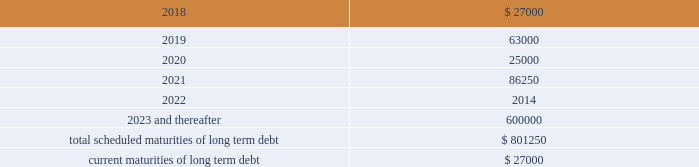Other long term debt in december 2012 , the company entered into a $ 50.0 million recourse loan collateralized by the land , buildings and tenant improvements comprising the company 2019s corporate headquarters .
The loan has a seven year term and maturity date of december 2019 .
The loan bears interest at one month libor plus a margin of 1.50% ( 1.50 % ) , and allows for prepayment without penalty .
The loan includes covenants and events of default substantially consistent with the company 2019s credit agreement discussed above .
The loan also requires prior approval of the lender for certain matters related to the property , including transfers of any interest in the property .
As of december 31 , 2017 and 2016 , the outstanding balance on the loan was $ 40.0 million and $ 42.0 million , respectively .
The weighted average interest rate on the loan was 2.5% ( 2.5 % ) and 2.0% ( 2.0 % ) for the years ended december 31 , 2017 and 2016 , respectively .
The following are the scheduled maturities of long term debt as of december 31 , 2017 : ( in thousands ) .
Interest expense , net was $ 34.5 million , $ 26.4 million , and $ 14.6 million for the years ended december 31 , 2017 , 2016 and 2015 , respectively .
Interest expense includes the amortization of deferred financing costs , bank fees , capital and built-to-suit lease interest and interest expense under the credit and other long term debt facilities .
Amortization of deferred financing costs was $ 1.3 million , $ 1.2 million , and $ 0.8 million for the years ended december 31 , 2017 , 2016 and 2015 , respectively .
The company monitors the financial health and stability of its lenders under the credit and other long term debt facilities , however during any period of significant instability in the credit markets lenders could be negatively impacted in their ability to perform under these facilities .
Commitments and contingencies obligations under operating leases the company leases warehouse space , office facilities , space for its brand and factory house stores and certain equipment under non-cancelable operating leases .
The leases expire at various dates through 2033 , excluding extensions at the company 2019s option , and include provisions for rental adjustments .
The table below includes executed lease agreements for brand and factory house stores that the company did not yet occupy as of december 31 , 2017 and does not include contingent rent the company may incur at its stores based on future sales above a specified minimum or payments made for maintenance , insurance and real estate taxes .
The following is a schedule of future minimum lease payments for non-cancelable real property operating leases as of december 31 , 2017 as well as .
What is the percentage increase in interest expense from 2016 to 2017? 
Computations: ((34.5 - 26.4) / 26.4)
Answer: 0.30682. 